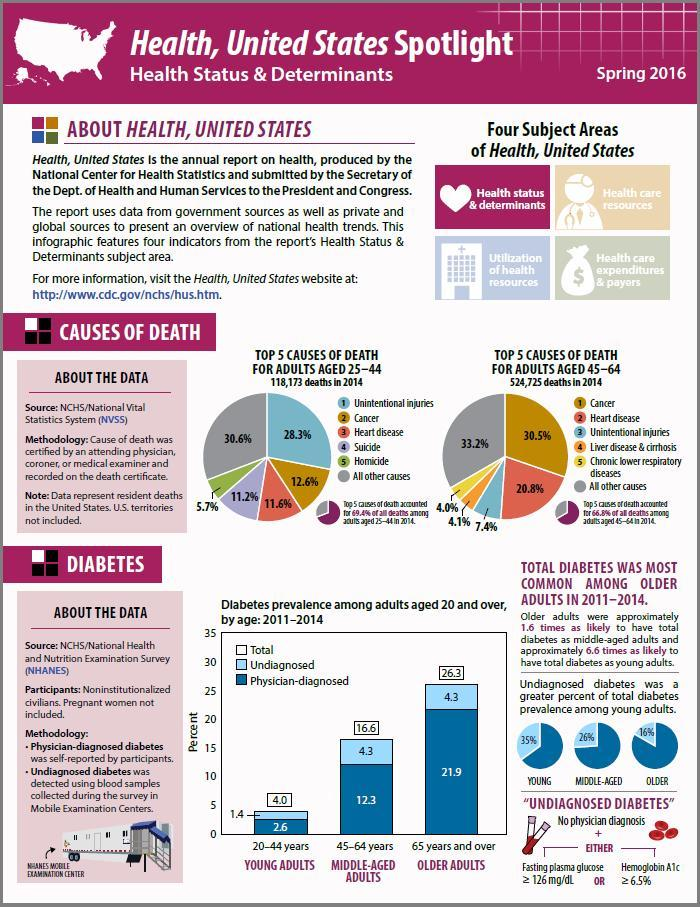Among young adults, what percentage of people had undiagnosed diabetes according to pie chart?
Answer the question with a short phrase. 35% In what percent of middle aged adults was diabetes undiagnosed during the year 2011-2014? 4.3 What percentage of people in the age 25-44 die from cancer and heart disease? 24.2% What is the most common case of death in adults aged 45-64? Cancer 